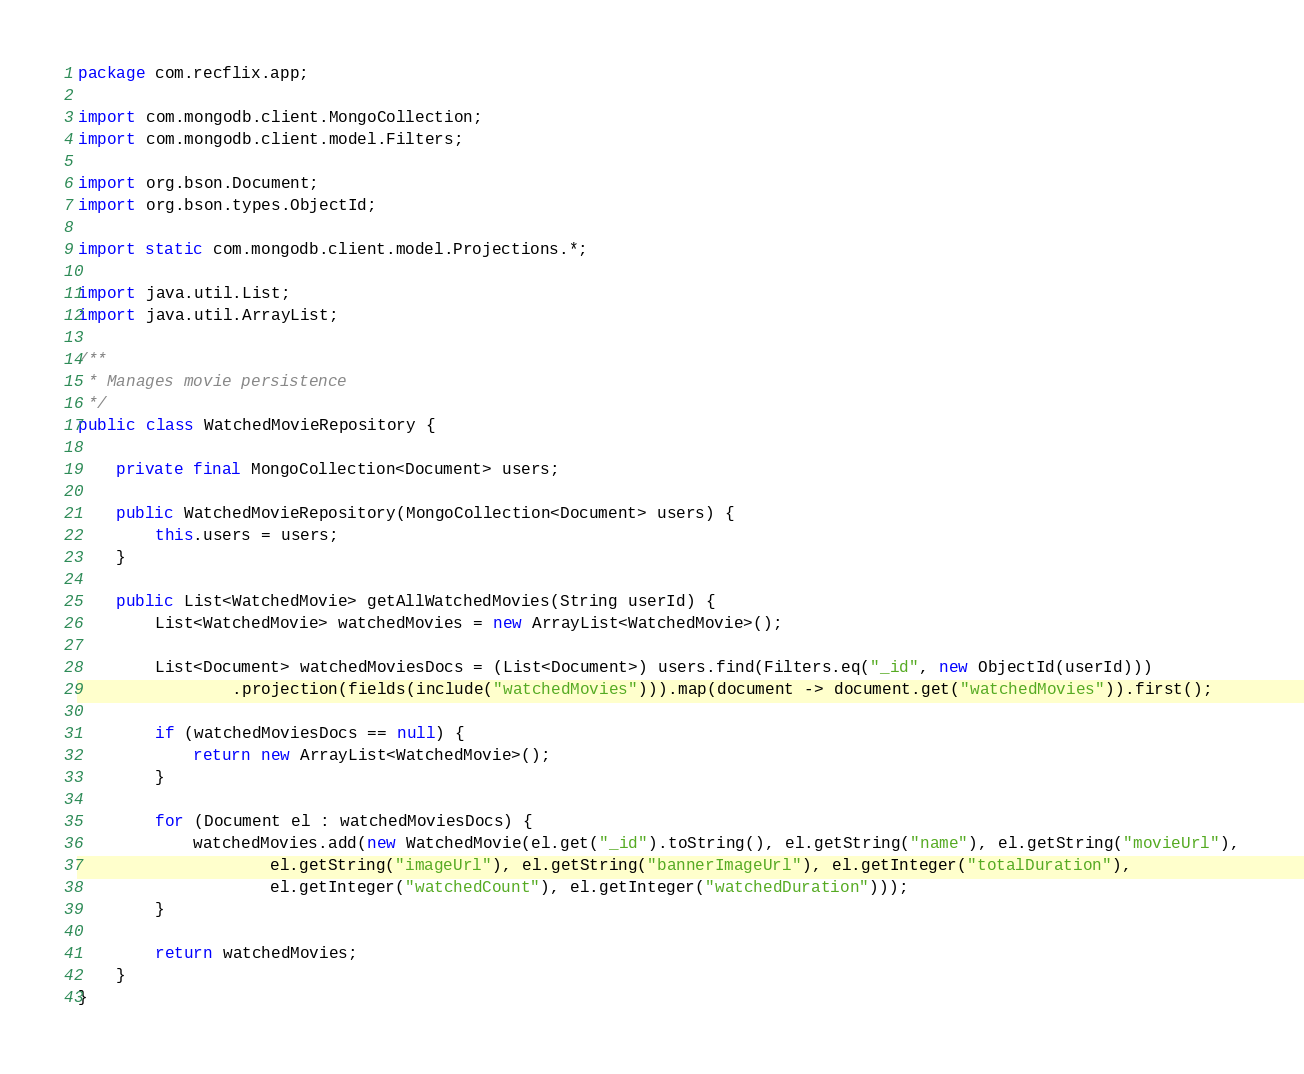Convert code to text. <code><loc_0><loc_0><loc_500><loc_500><_Java_>package com.recflix.app;

import com.mongodb.client.MongoCollection;
import com.mongodb.client.model.Filters;

import org.bson.Document;
import org.bson.types.ObjectId;

import static com.mongodb.client.model.Projections.*;

import java.util.List;
import java.util.ArrayList;

/**
 * Manages movie persistence
 */
public class WatchedMovieRepository {

    private final MongoCollection<Document> users;

    public WatchedMovieRepository(MongoCollection<Document> users) {
        this.users = users;
    }

    public List<WatchedMovie> getAllWatchedMovies(String userId) {
        List<WatchedMovie> watchedMovies = new ArrayList<WatchedMovie>();

        List<Document> watchedMoviesDocs = (List<Document>) users.find(Filters.eq("_id", new ObjectId(userId)))
                .projection(fields(include("watchedMovies"))).map(document -> document.get("watchedMovies")).first();

        if (watchedMoviesDocs == null) {
            return new ArrayList<WatchedMovie>();
        }

        for (Document el : watchedMoviesDocs) {
            watchedMovies.add(new WatchedMovie(el.get("_id").toString(), el.getString("name"), el.getString("movieUrl"),
                    el.getString("imageUrl"), el.getString("bannerImageUrl"), el.getInteger("totalDuration"),
                    el.getInteger("watchedCount"), el.getInteger("watchedDuration")));
        }

        return watchedMovies;
    }
}
</code> 